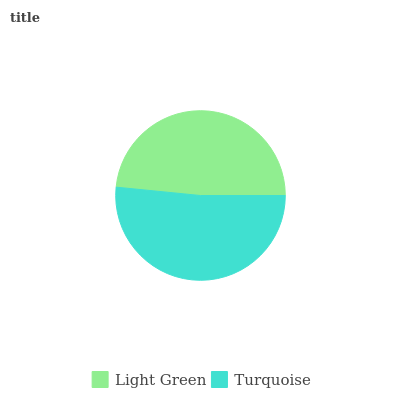Is Light Green the minimum?
Answer yes or no. Yes. Is Turquoise the maximum?
Answer yes or no. Yes. Is Turquoise the minimum?
Answer yes or no. No. Is Turquoise greater than Light Green?
Answer yes or no. Yes. Is Light Green less than Turquoise?
Answer yes or no. Yes. Is Light Green greater than Turquoise?
Answer yes or no. No. Is Turquoise less than Light Green?
Answer yes or no. No. Is Turquoise the high median?
Answer yes or no. Yes. Is Light Green the low median?
Answer yes or no. Yes. Is Light Green the high median?
Answer yes or no. No. Is Turquoise the low median?
Answer yes or no. No. 